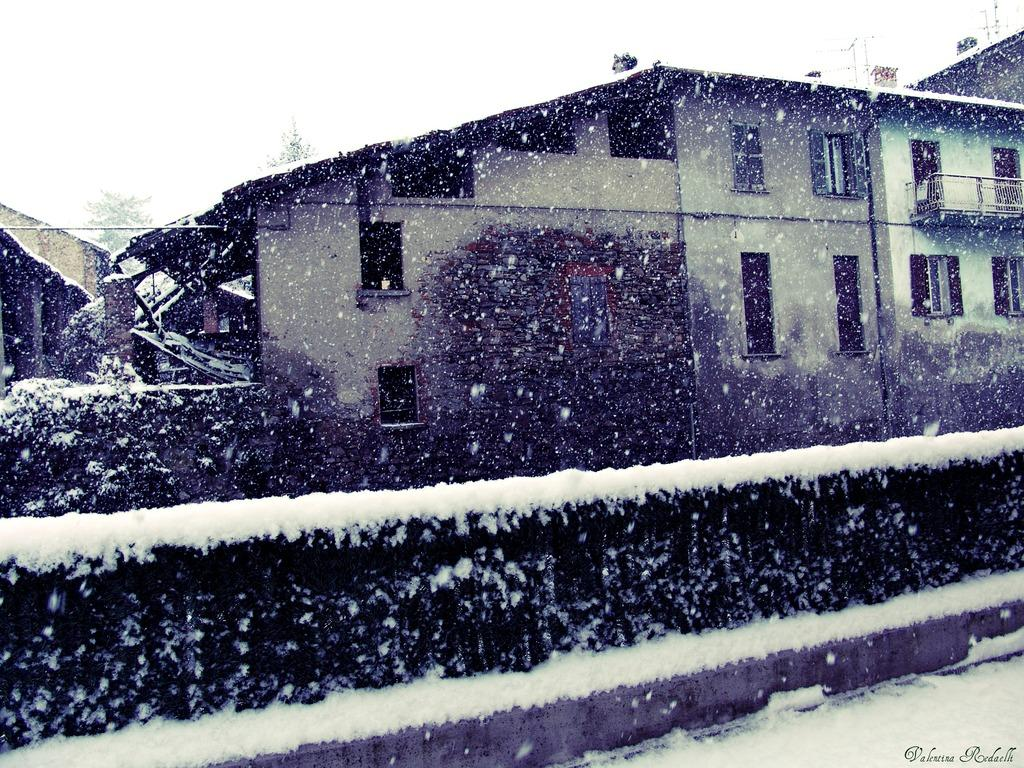What type of structures can be seen in the image? The image contains buildings. What is the condition of the plants in the image? The plants are covered with snow in the image. Where are the plants located in relation to the rest of the image? The plants are in the front of the image. What is visible at the bottom of the image? There is a road at the bottom of the image. What is visible at the top of the image? The sky is visible at the top of the image. Can you tell me how many giraffes are visible in the image? There are no giraffes present in the image. What type of watch is the person wearing in the image? There is no person wearing a watch in the image. 